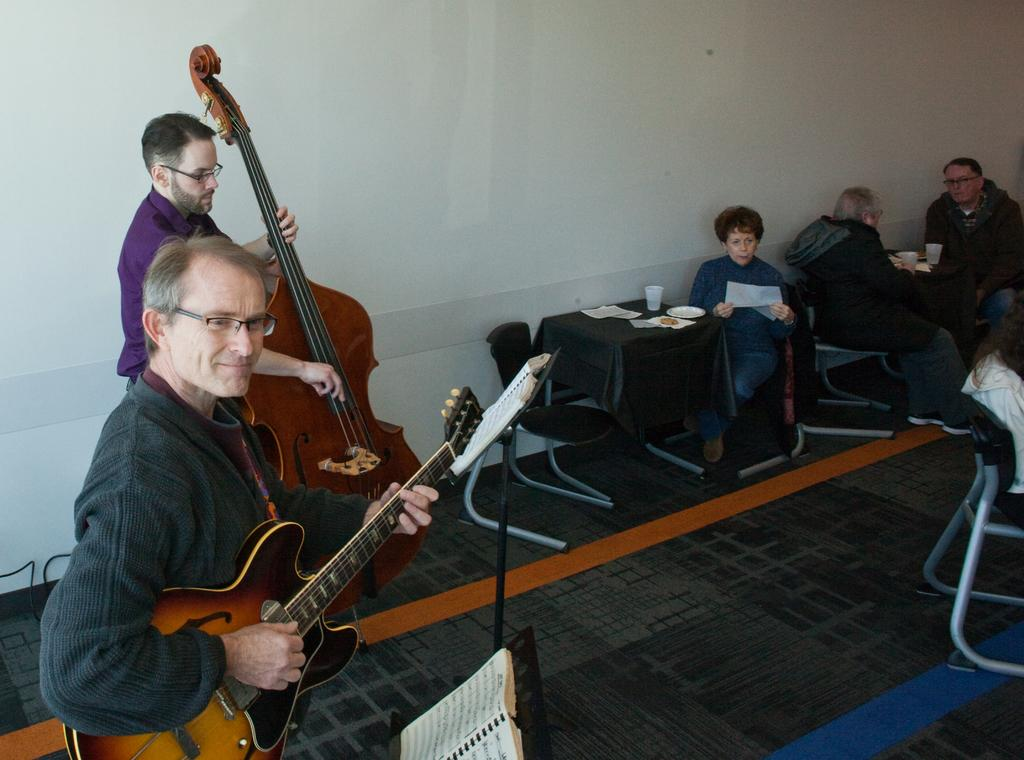How many people are visible in the image? There are two people standing in the image. What are the standing people holding? The two people are holding a guitar. What are the other people in the image doing? There are additional people sitting in front of the standing people. What type of wrench is being used to wash the guitar in the image? There is no wrench or washing activity present in the image; the standing people are simply holding a guitar. 